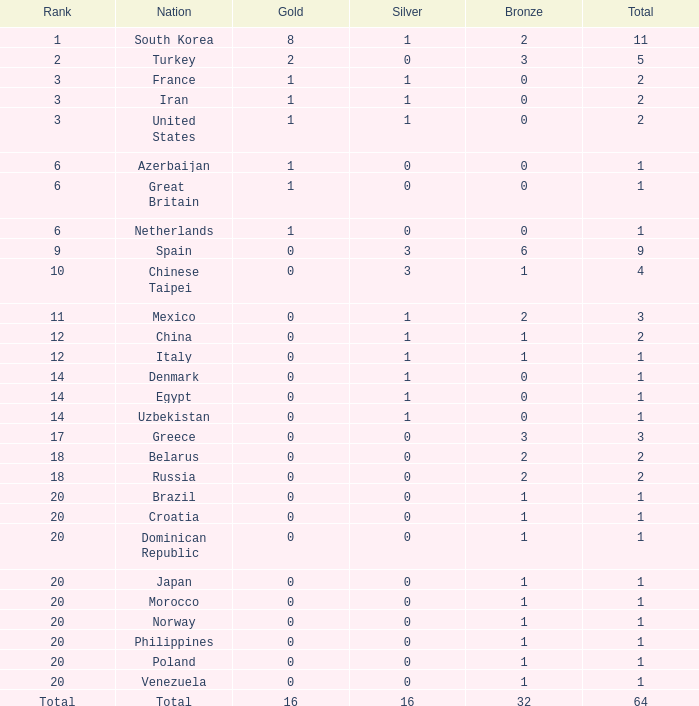What is the average total medals of the nation ranked 1 with less than 1 silver? None. 